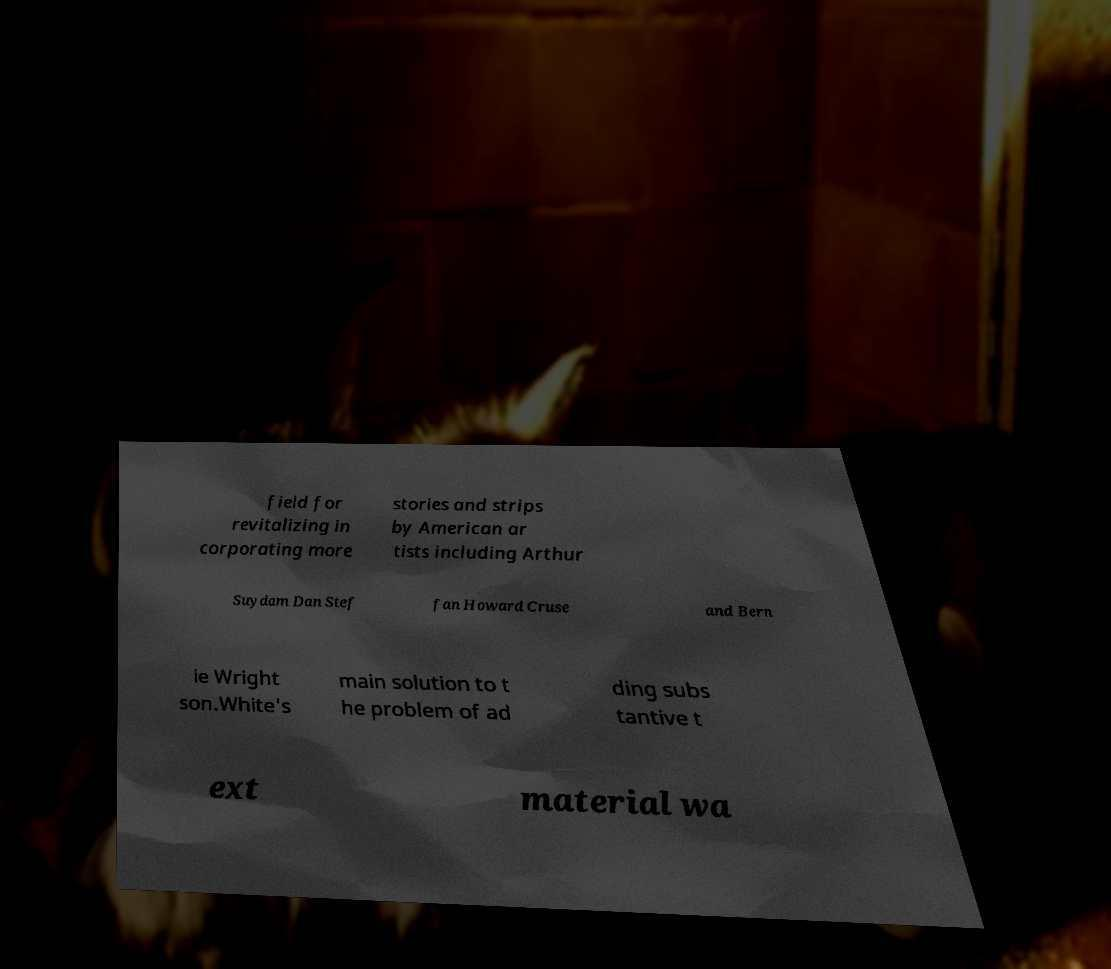I need the written content from this picture converted into text. Can you do that? field for revitalizing in corporating more stories and strips by American ar tists including Arthur Suydam Dan Stef fan Howard Cruse and Bern ie Wright son.White's main solution to t he problem of ad ding subs tantive t ext material wa 